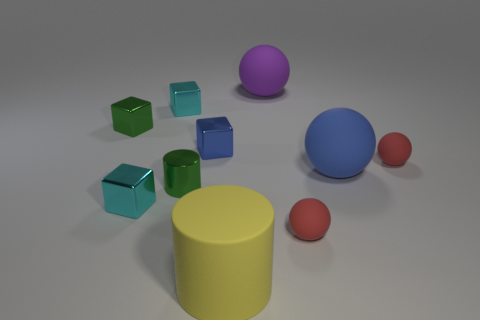What number of other things are the same shape as the blue rubber thing?
Provide a short and direct response. 3. What shape is the blue shiny thing right of the small green shiny block?
Your response must be concise. Cube. Are there any gray cylinders made of the same material as the large blue ball?
Give a very brief answer. No. Do the big matte thing that is behind the small blue cube and the rubber cylinder have the same color?
Your response must be concise. No. The blue metal block has what size?
Give a very brief answer. Small. Are there any small rubber spheres to the right of the thing to the left of the cyan shiny thing in front of the blue matte ball?
Offer a very short reply. Yes. There is a large cylinder; how many red rubber balls are behind it?
Your answer should be compact. 2. What number of blocks have the same color as the tiny cylinder?
Give a very brief answer. 1. What number of objects are either small metal cylinders that are in front of the large blue ball or objects on the left side of the tiny green cylinder?
Offer a very short reply. 4. Is the number of tiny red rubber things greater than the number of large things?
Ensure brevity in your answer.  No. 